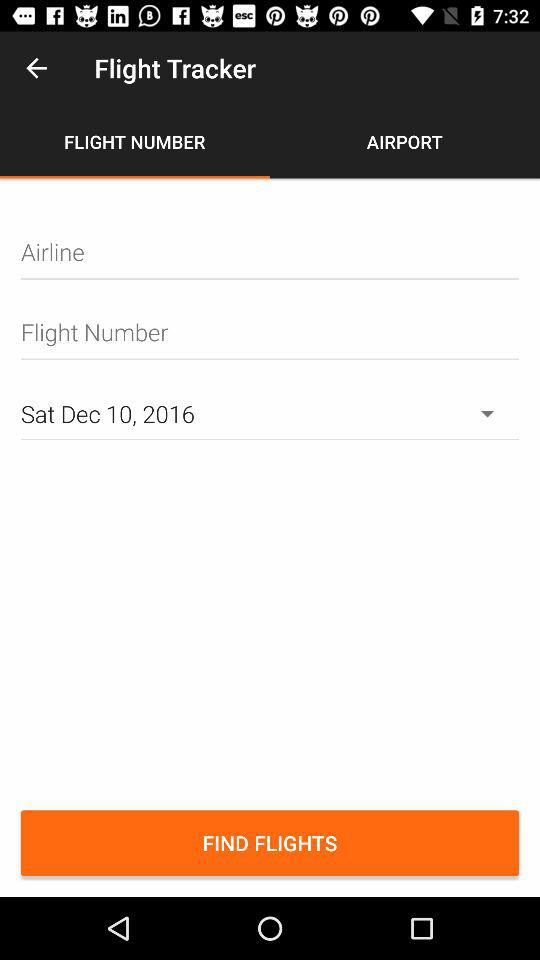Which is the date? The date is Saturday, December 10, 2016. 